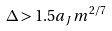<formula> <loc_0><loc_0><loc_500><loc_500>\Delta > 1 . 5 a _ { J } m ^ { 2 / 7 }</formula> 